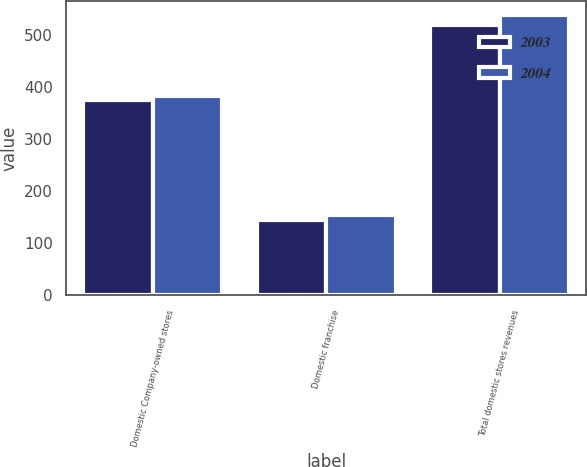Convert chart to OTSL. <chart><loc_0><loc_0><loc_500><loc_500><stacked_bar_chart><ecel><fcel>Domestic Company-owned stores<fcel>Domestic franchise<fcel>Total domestic stores revenues<nl><fcel>2003<fcel>375.4<fcel>144.5<fcel>519.9<nl><fcel>2004<fcel>382.5<fcel>155<fcel>537.5<nl></chart> 